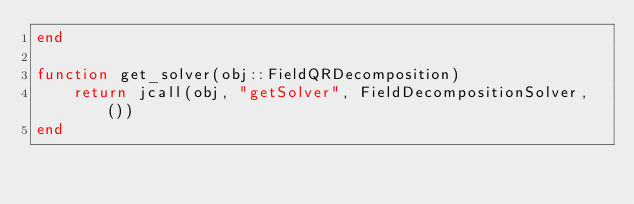<code> <loc_0><loc_0><loc_500><loc_500><_Julia_>end

function get_solver(obj::FieldQRDecomposition)
    return jcall(obj, "getSolver", FieldDecompositionSolver, ())
end

</code> 